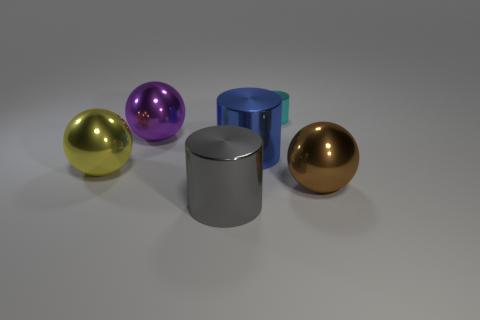Subtract all large metallic cylinders. How many cylinders are left? 1 Add 1 tiny gray cylinders. How many objects exist? 7 Subtract 1 spheres. How many spheres are left? 2 Subtract all brown cylinders. Subtract all blue balls. How many cylinders are left? 3 Subtract 0 gray cubes. How many objects are left? 6 Subtract all yellow metallic things. Subtract all cyan cylinders. How many objects are left? 4 Add 1 large blue cylinders. How many large blue cylinders are left? 2 Add 2 green blocks. How many green blocks exist? 2 